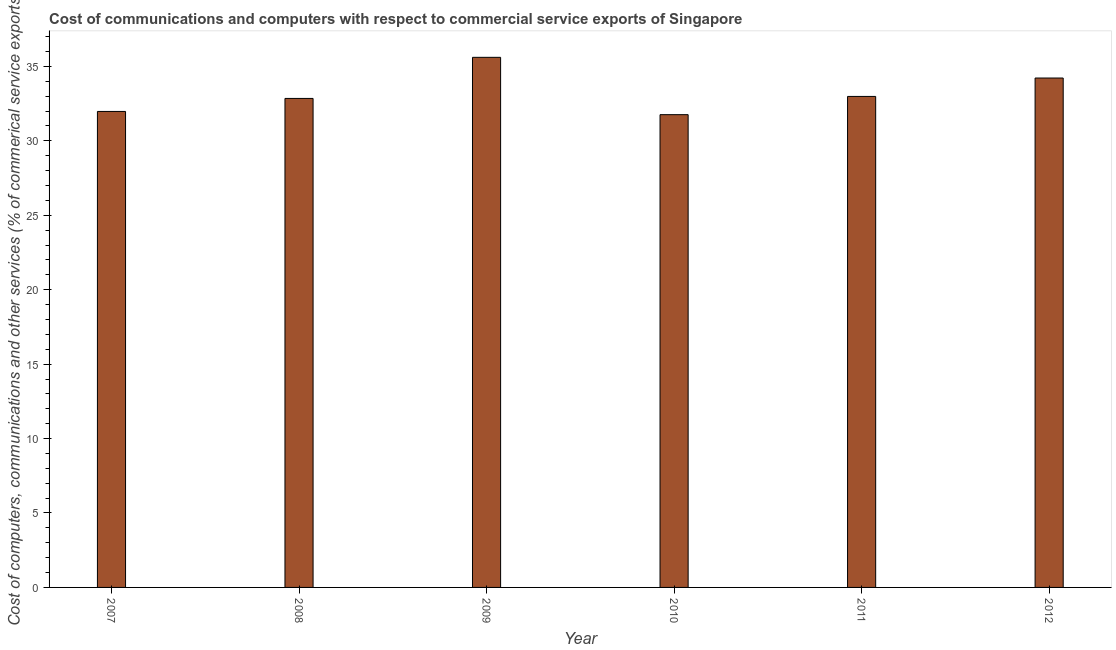Does the graph contain grids?
Your answer should be compact. No. What is the title of the graph?
Provide a succinct answer. Cost of communications and computers with respect to commercial service exports of Singapore. What is the label or title of the X-axis?
Provide a short and direct response. Year. What is the label or title of the Y-axis?
Your response must be concise. Cost of computers, communications and other services (% of commerical service exports). What is the  computer and other services in 2008?
Provide a succinct answer. 32.85. Across all years, what is the maximum cost of communications?
Make the answer very short. 35.61. Across all years, what is the minimum  computer and other services?
Keep it short and to the point. 31.76. In which year was the cost of communications maximum?
Offer a very short reply. 2009. What is the sum of the cost of communications?
Your answer should be compact. 199.4. What is the difference between the cost of communications in 2007 and 2008?
Make the answer very short. -0.88. What is the average cost of communications per year?
Make the answer very short. 33.23. What is the median cost of communications?
Make the answer very short. 32.92. In how many years, is the cost of communications greater than 22 %?
Your answer should be very brief. 6. What is the ratio of the cost of communications in 2010 to that in 2012?
Your answer should be very brief. 0.93. Is the cost of communications in 2008 less than that in 2010?
Give a very brief answer. No. What is the difference between the highest and the second highest  computer and other services?
Offer a very short reply. 1.39. What is the difference between the highest and the lowest  computer and other services?
Give a very brief answer. 3.85. How many bars are there?
Your response must be concise. 6. Are all the bars in the graph horizontal?
Provide a succinct answer. No. Are the values on the major ticks of Y-axis written in scientific E-notation?
Your response must be concise. No. What is the Cost of computers, communications and other services (% of commerical service exports) of 2007?
Make the answer very short. 31.98. What is the Cost of computers, communications and other services (% of commerical service exports) of 2008?
Keep it short and to the point. 32.85. What is the Cost of computers, communications and other services (% of commerical service exports) in 2009?
Your answer should be very brief. 35.61. What is the Cost of computers, communications and other services (% of commerical service exports) of 2010?
Your answer should be very brief. 31.76. What is the Cost of computers, communications and other services (% of commerical service exports) of 2011?
Keep it short and to the point. 32.98. What is the Cost of computers, communications and other services (% of commerical service exports) in 2012?
Offer a very short reply. 34.22. What is the difference between the Cost of computers, communications and other services (% of commerical service exports) in 2007 and 2008?
Offer a very short reply. -0.88. What is the difference between the Cost of computers, communications and other services (% of commerical service exports) in 2007 and 2009?
Provide a short and direct response. -3.64. What is the difference between the Cost of computers, communications and other services (% of commerical service exports) in 2007 and 2010?
Provide a succinct answer. 0.22. What is the difference between the Cost of computers, communications and other services (% of commerical service exports) in 2007 and 2011?
Provide a succinct answer. -1.01. What is the difference between the Cost of computers, communications and other services (% of commerical service exports) in 2007 and 2012?
Provide a short and direct response. -2.25. What is the difference between the Cost of computers, communications and other services (% of commerical service exports) in 2008 and 2009?
Your answer should be very brief. -2.76. What is the difference between the Cost of computers, communications and other services (% of commerical service exports) in 2008 and 2010?
Keep it short and to the point. 1.09. What is the difference between the Cost of computers, communications and other services (% of commerical service exports) in 2008 and 2011?
Make the answer very short. -0.13. What is the difference between the Cost of computers, communications and other services (% of commerical service exports) in 2008 and 2012?
Your answer should be compact. -1.37. What is the difference between the Cost of computers, communications and other services (% of commerical service exports) in 2009 and 2010?
Your answer should be very brief. 3.85. What is the difference between the Cost of computers, communications and other services (% of commerical service exports) in 2009 and 2011?
Provide a short and direct response. 2.63. What is the difference between the Cost of computers, communications and other services (% of commerical service exports) in 2009 and 2012?
Provide a succinct answer. 1.39. What is the difference between the Cost of computers, communications and other services (% of commerical service exports) in 2010 and 2011?
Provide a short and direct response. -1.22. What is the difference between the Cost of computers, communications and other services (% of commerical service exports) in 2010 and 2012?
Keep it short and to the point. -2.46. What is the difference between the Cost of computers, communications and other services (% of commerical service exports) in 2011 and 2012?
Your response must be concise. -1.24. What is the ratio of the Cost of computers, communications and other services (% of commerical service exports) in 2007 to that in 2008?
Your answer should be compact. 0.97. What is the ratio of the Cost of computers, communications and other services (% of commerical service exports) in 2007 to that in 2009?
Keep it short and to the point. 0.9. What is the ratio of the Cost of computers, communications and other services (% of commerical service exports) in 2007 to that in 2011?
Give a very brief answer. 0.97. What is the ratio of the Cost of computers, communications and other services (% of commerical service exports) in 2007 to that in 2012?
Your answer should be compact. 0.93. What is the ratio of the Cost of computers, communications and other services (% of commerical service exports) in 2008 to that in 2009?
Provide a short and direct response. 0.92. What is the ratio of the Cost of computers, communications and other services (% of commerical service exports) in 2008 to that in 2010?
Make the answer very short. 1.03. What is the ratio of the Cost of computers, communications and other services (% of commerical service exports) in 2009 to that in 2010?
Give a very brief answer. 1.12. What is the ratio of the Cost of computers, communications and other services (% of commerical service exports) in 2009 to that in 2012?
Make the answer very short. 1.04. What is the ratio of the Cost of computers, communications and other services (% of commerical service exports) in 2010 to that in 2011?
Keep it short and to the point. 0.96. What is the ratio of the Cost of computers, communications and other services (% of commerical service exports) in 2010 to that in 2012?
Offer a very short reply. 0.93. 